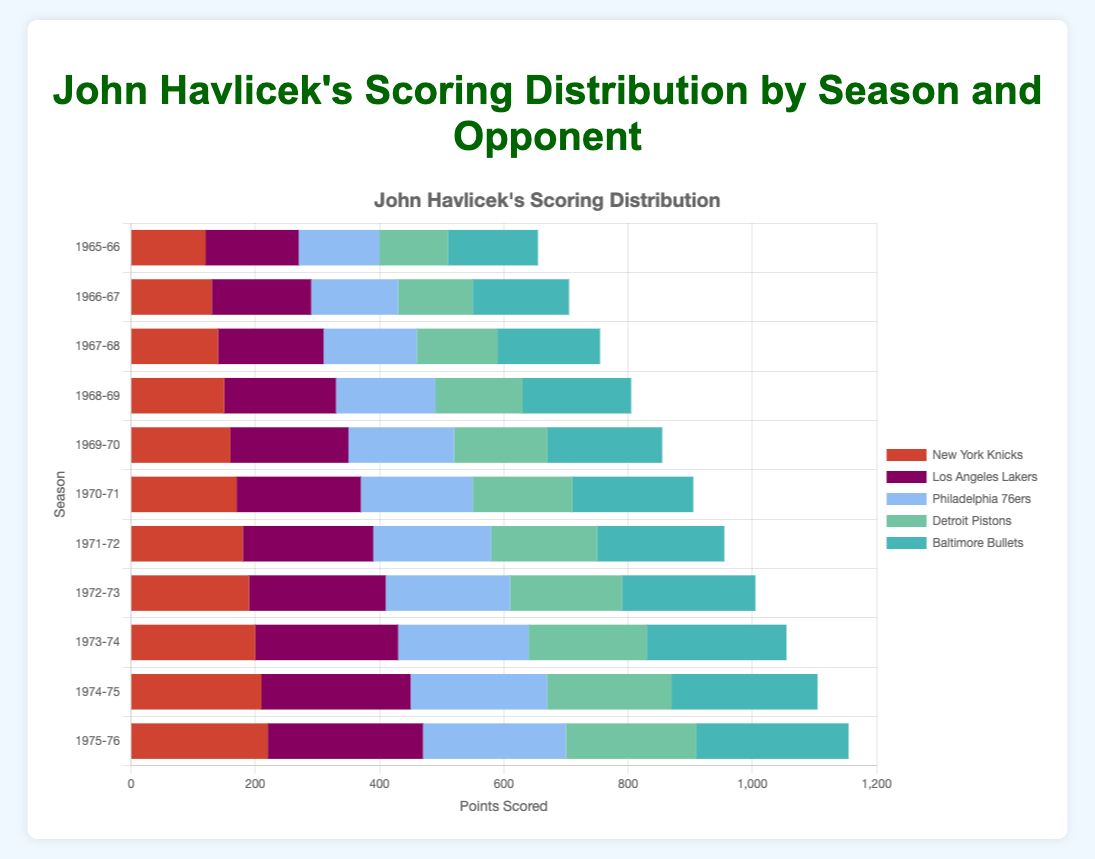What's the average number of points scored by John Havlicek against the New York Knicks over all seasons? First, sum up the points scored against the New York Knicks for all seasons: (120 + 130 + 140 + 150 + 160 + 170 + 180 + 190 + 200 + 210 + 220) = 1970. Then, divide by the number of seasons (11): 1970 / 11 = 179.09
Answer: 179.09 Which team did John Havlicek score the most points against in the 1975-76 season? Locate the bar segment for the 1975-76 season and check the values for each team. The highest value is 250 scored against the Los Angeles Lakers.
Answer: Los Angeles Lakers In which season did John Havlicek score more points against the Philadelphia 76ers compared to the Detroit Pistons? Check the bar lengths for Philadelphia 76ers and Detroit Pistons for each season. Subtract the points for the Pistons from the points for the 76ers: 130 - 110 (1965-66), 140 - 120 (1966-67), 150 - 130 (1967-68), 160 - 140 (1968-69), 170 - 150 (1969-70), 180 - 160 (1970-71), 190 - 170 (1971-72), 200 - 180 (1972-73), 210 - 190 (1973-74), 220 - 200 (1974-75), 230 - 210 (1975-76). In all seasons, the points against the 76ers are higher.
Answer: All seasons How did John Havlicek's points against the Baltimore Bullets change from the 1965-66 season to the 1975-76 season? Look at and compare the bar segments for Baltimore Bullets in the 1965-66 season and the 1975-76 season. In 1965-66, the points are 145, and in 1975-76, they are 245. Subtraction: 245 - 145 = 100
Answer: Increased by 100 Which season shows the highest total points scored against all teams combined? Sum the points for all teams in each season and compare to find the highest total. Example: 
1965-66: 120 + 150 + 130 + 110 + 145 = 655,
1966-67: 130 + 160 + 140 + 120 + 155 = 705,
...
1975-76: 220 + 250 + 230 + 210 + 245 = 1155. The highest total is in the 1975-76 season (1155 points).
Answer: 1975-76 Which season shows the most balanced scoring distribution across all teams? Observe the consistency in bar segments' lengths for each team within a season. The season with bars of nearly equal length for all teams is the most balanced; in this case, visually check and compare distributions. Notice that 1965-66 appears relatively balanced.
Answer: 1965-66 Did John Havlicek's scoring improve or decline against the Los Angeles Lakers from 1965-66 to 1975-76? Compare the heights of the bars representing points against the Los Angeles Lakers from 1965-66 (150 points) and 1975-76 (250 points). The points increased.
Answer: Improved On average, for which team did John Havlicek score the least points? Calculate the average points for each team across all seasons by summing and dividing by the number of seasons. Compare averages and find the minimum: 
New York Knicks: 1790
Los Angeles Lakers: 2100
Philadelphia 76ers: 1980
Detroit Pistons: 1720
Baltimore Bullets: 2050 
Identify the smallest average: 1720 / 11 ≈ 156.36 for the Detroit Pistons.
Answer: Detroit Pistons 